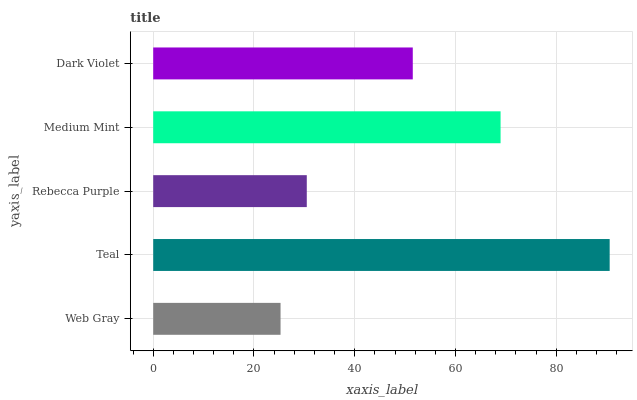Is Web Gray the minimum?
Answer yes or no. Yes. Is Teal the maximum?
Answer yes or no. Yes. Is Rebecca Purple the minimum?
Answer yes or no. No. Is Rebecca Purple the maximum?
Answer yes or no. No. Is Teal greater than Rebecca Purple?
Answer yes or no. Yes. Is Rebecca Purple less than Teal?
Answer yes or no. Yes. Is Rebecca Purple greater than Teal?
Answer yes or no. No. Is Teal less than Rebecca Purple?
Answer yes or no. No. Is Dark Violet the high median?
Answer yes or no. Yes. Is Dark Violet the low median?
Answer yes or no. Yes. Is Rebecca Purple the high median?
Answer yes or no. No. Is Rebecca Purple the low median?
Answer yes or no. No. 